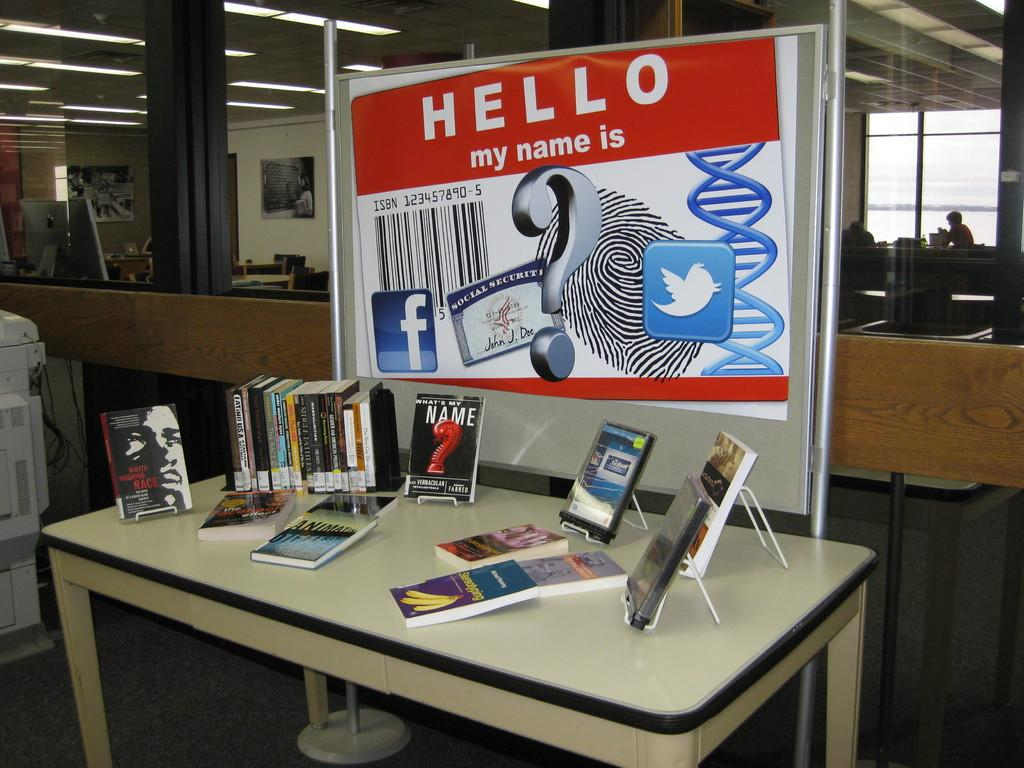What type of furniture is present in the image? There is a table in the image. What is placed on the table? There are lots of books on the table. Is there any other object or decoration in the image? Yes, there is a banner in the image. What type of glove is being used to hold the books on the table? There is no glove present in the image, and the books are not being held by any object or person. 